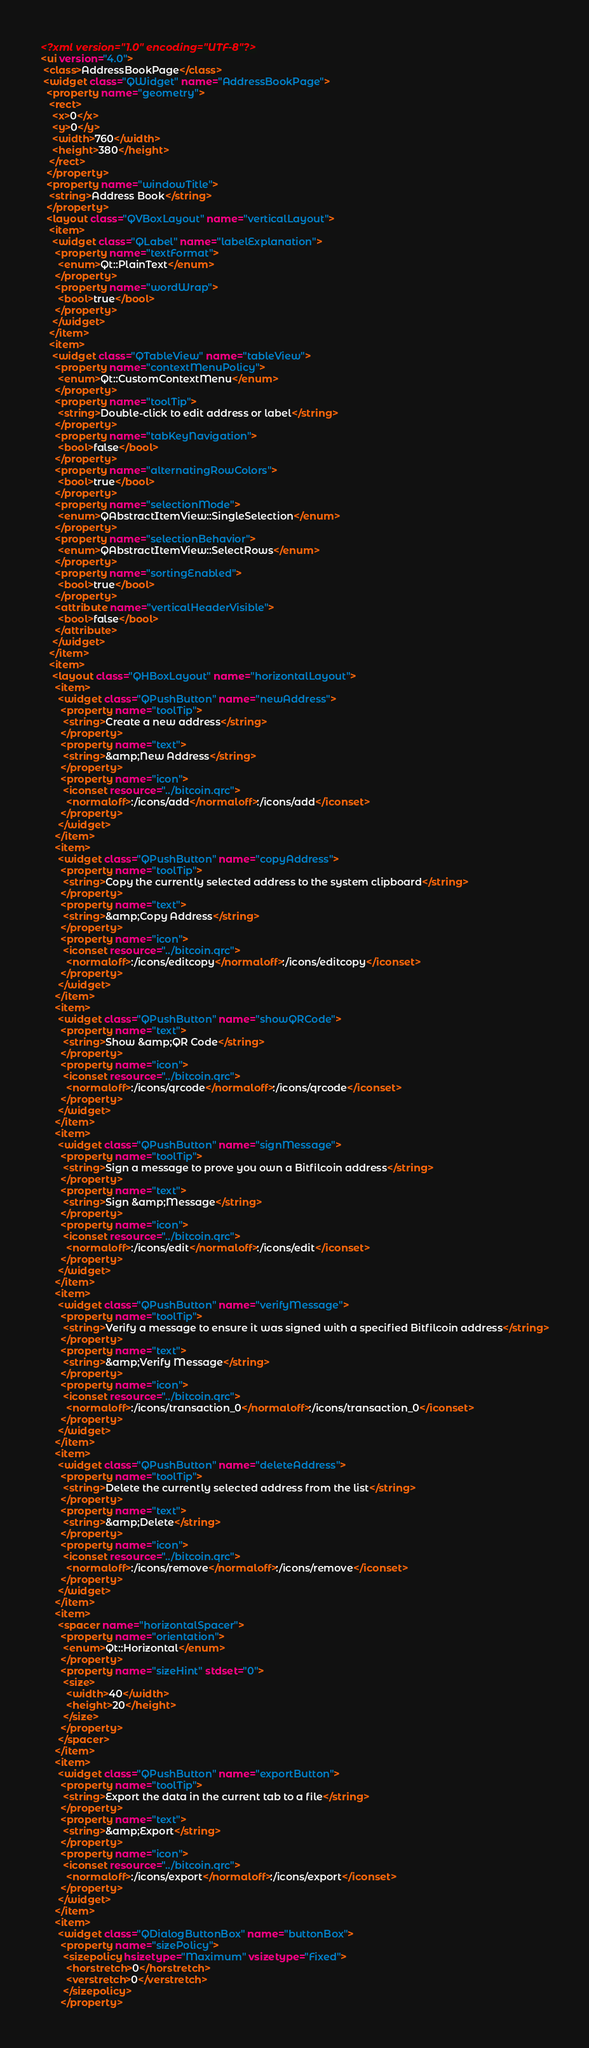Convert code to text. <code><loc_0><loc_0><loc_500><loc_500><_XML_><?xml version="1.0" encoding="UTF-8"?>
<ui version="4.0">
 <class>AddressBookPage</class>
 <widget class="QWidget" name="AddressBookPage">
  <property name="geometry">
   <rect>
    <x>0</x>
    <y>0</y>
    <width>760</width>
    <height>380</height>
   </rect>
  </property>
  <property name="windowTitle">
   <string>Address Book</string>
  </property>
  <layout class="QVBoxLayout" name="verticalLayout">
   <item>
    <widget class="QLabel" name="labelExplanation">
     <property name="textFormat">
      <enum>Qt::PlainText</enum>
     </property>
     <property name="wordWrap">
      <bool>true</bool>
     </property>
    </widget>
   </item>
   <item>
    <widget class="QTableView" name="tableView">
     <property name="contextMenuPolicy">
      <enum>Qt::CustomContextMenu</enum>
     </property>
     <property name="toolTip">
      <string>Double-click to edit address or label</string>
     </property>
     <property name="tabKeyNavigation">
      <bool>false</bool>
     </property>
     <property name="alternatingRowColors">
      <bool>true</bool>
     </property>
     <property name="selectionMode">
      <enum>QAbstractItemView::SingleSelection</enum>
     </property>
     <property name="selectionBehavior">
      <enum>QAbstractItemView::SelectRows</enum>
     </property>
     <property name="sortingEnabled">
      <bool>true</bool>
     </property>
     <attribute name="verticalHeaderVisible">
      <bool>false</bool>
     </attribute>
    </widget>
   </item>
   <item>
    <layout class="QHBoxLayout" name="horizontalLayout">
     <item>
      <widget class="QPushButton" name="newAddress">
       <property name="toolTip">
        <string>Create a new address</string>
       </property>
       <property name="text">
        <string>&amp;New Address</string>
       </property>
       <property name="icon">
        <iconset resource="../bitcoin.qrc">
         <normaloff>:/icons/add</normaloff>:/icons/add</iconset>
       </property>
      </widget>
     </item>
     <item>
      <widget class="QPushButton" name="copyAddress">
       <property name="toolTip">
        <string>Copy the currently selected address to the system clipboard</string>
       </property>
       <property name="text">
        <string>&amp;Copy Address</string>
       </property>
       <property name="icon">
        <iconset resource="../bitcoin.qrc">
         <normaloff>:/icons/editcopy</normaloff>:/icons/editcopy</iconset>
       </property>
      </widget>
     </item>
     <item>
      <widget class="QPushButton" name="showQRCode">
       <property name="text">
        <string>Show &amp;QR Code</string>
       </property>
       <property name="icon">
        <iconset resource="../bitcoin.qrc">
         <normaloff>:/icons/qrcode</normaloff>:/icons/qrcode</iconset>
       </property>
      </widget>
     </item>
     <item>
      <widget class="QPushButton" name="signMessage">
       <property name="toolTip">
        <string>Sign a message to prove you own a Bitfilcoin address</string>
       </property>
       <property name="text">
        <string>Sign &amp;Message</string>
       </property>
       <property name="icon">
        <iconset resource="../bitcoin.qrc">
         <normaloff>:/icons/edit</normaloff>:/icons/edit</iconset>
       </property>
      </widget>
     </item>
     <item>
      <widget class="QPushButton" name="verifyMessage">
       <property name="toolTip">
        <string>Verify a message to ensure it was signed with a specified Bitfilcoin address</string>
       </property>
       <property name="text">
        <string>&amp;Verify Message</string>
       </property>
       <property name="icon">
        <iconset resource="../bitcoin.qrc">
         <normaloff>:/icons/transaction_0</normaloff>:/icons/transaction_0</iconset>
       </property>
      </widget>
     </item>
     <item>
      <widget class="QPushButton" name="deleteAddress">
       <property name="toolTip">
        <string>Delete the currently selected address from the list</string>
       </property>
       <property name="text">
        <string>&amp;Delete</string>
       </property>
       <property name="icon">
        <iconset resource="../bitcoin.qrc">
         <normaloff>:/icons/remove</normaloff>:/icons/remove</iconset>
       </property>
      </widget>
     </item>
     <item>
      <spacer name="horizontalSpacer">
       <property name="orientation">
        <enum>Qt::Horizontal</enum>
       </property>
       <property name="sizeHint" stdset="0">
        <size>
         <width>40</width>
         <height>20</height>
        </size>
       </property>
      </spacer>
     </item>
     <item>
      <widget class="QPushButton" name="exportButton">
       <property name="toolTip">
        <string>Export the data in the current tab to a file</string>
       </property>
       <property name="text">
        <string>&amp;Export</string>
       </property>
       <property name="icon">
        <iconset resource="../bitcoin.qrc">
         <normaloff>:/icons/export</normaloff>:/icons/export</iconset>
       </property>
      </widget>
     </item>
     <item>
      <widget class="QDialogButtonBox" name="buttonBox">
       <property name="sizePolicy">
        <sizepolicy hsizetype="Maximum" vsizetype="Fixed">
         <horstretch>0</horstretch>
         <verstretch>0</verstretch>
        </sizepolicy>
       </property></code> 